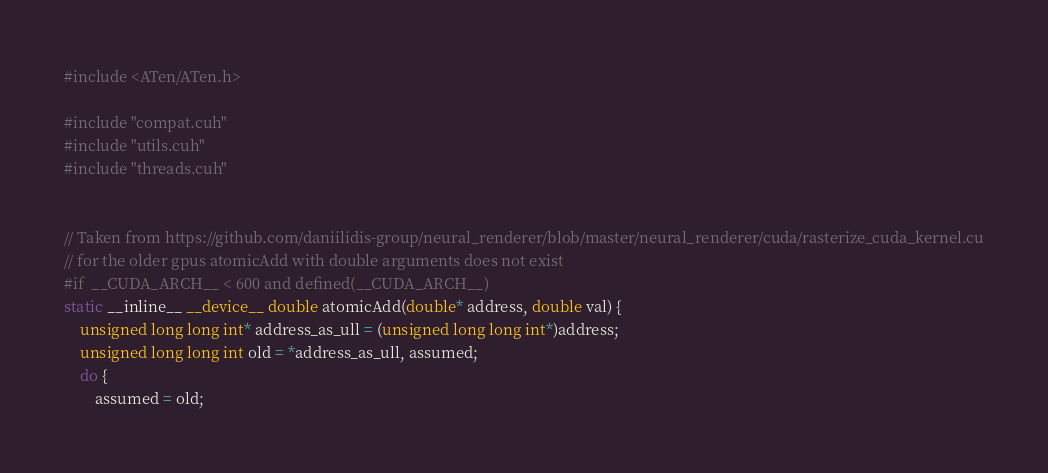Convert code to text. <code><loc_0><loc_0><loc_500><loc_500><_Cuda_>#include <ATen/ATen.h>

#include "compat.cuh"
#include "utils.cuh"
#include "threads.cuh"


// Taken from https://github.com/daniilidis-group/neural_renderer/blob/master/neural_renderer/cuda/rasterize_cuda_kernel.cu
// for the older gpus atomicAdd with double arguments does not exist
#if  __CUDA_ARCH__ < 600 and defined(__CUDA_ARCH__)
static __inline__ __device__ double atomicAdd(double* address, double val) {
    unsigned long long int* address_as_ull = (unsigned long long int*)address;
    unsigned long long int old = *address_as_ull, assumed;
    do {
        assumed = old;</code> 